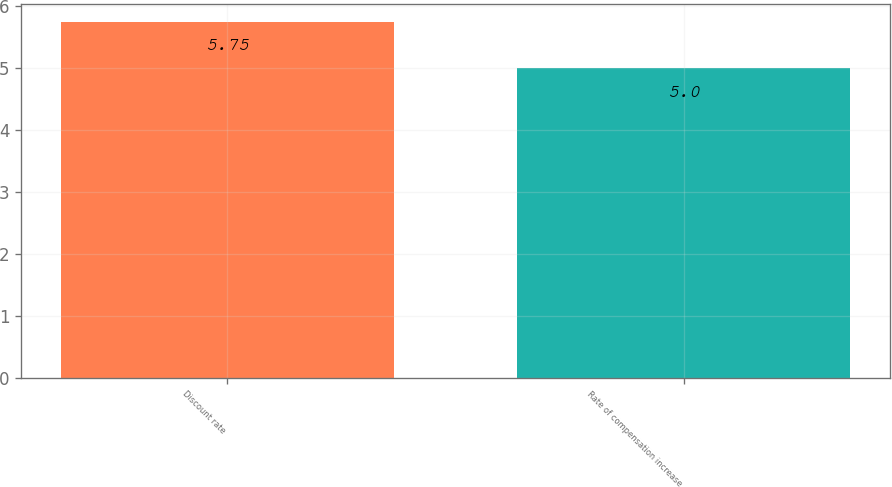Convert chart. <chart><loc_0><loc_0><loc_500><loc_500><bar_chart><fcel>Discount rate<fcel>Rate of compensation increase<nl><fcel>5.75<fcel>5<nl></chart> 